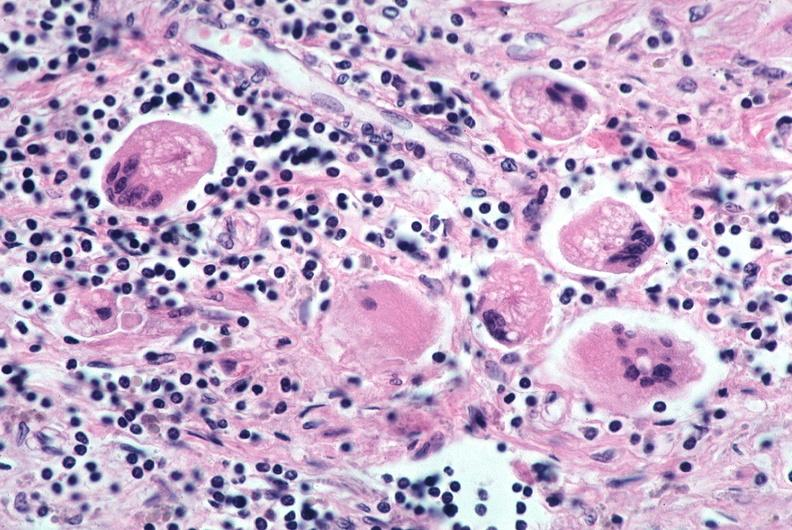what is present?
Answer the question using a single word or phrase. Respiratory 